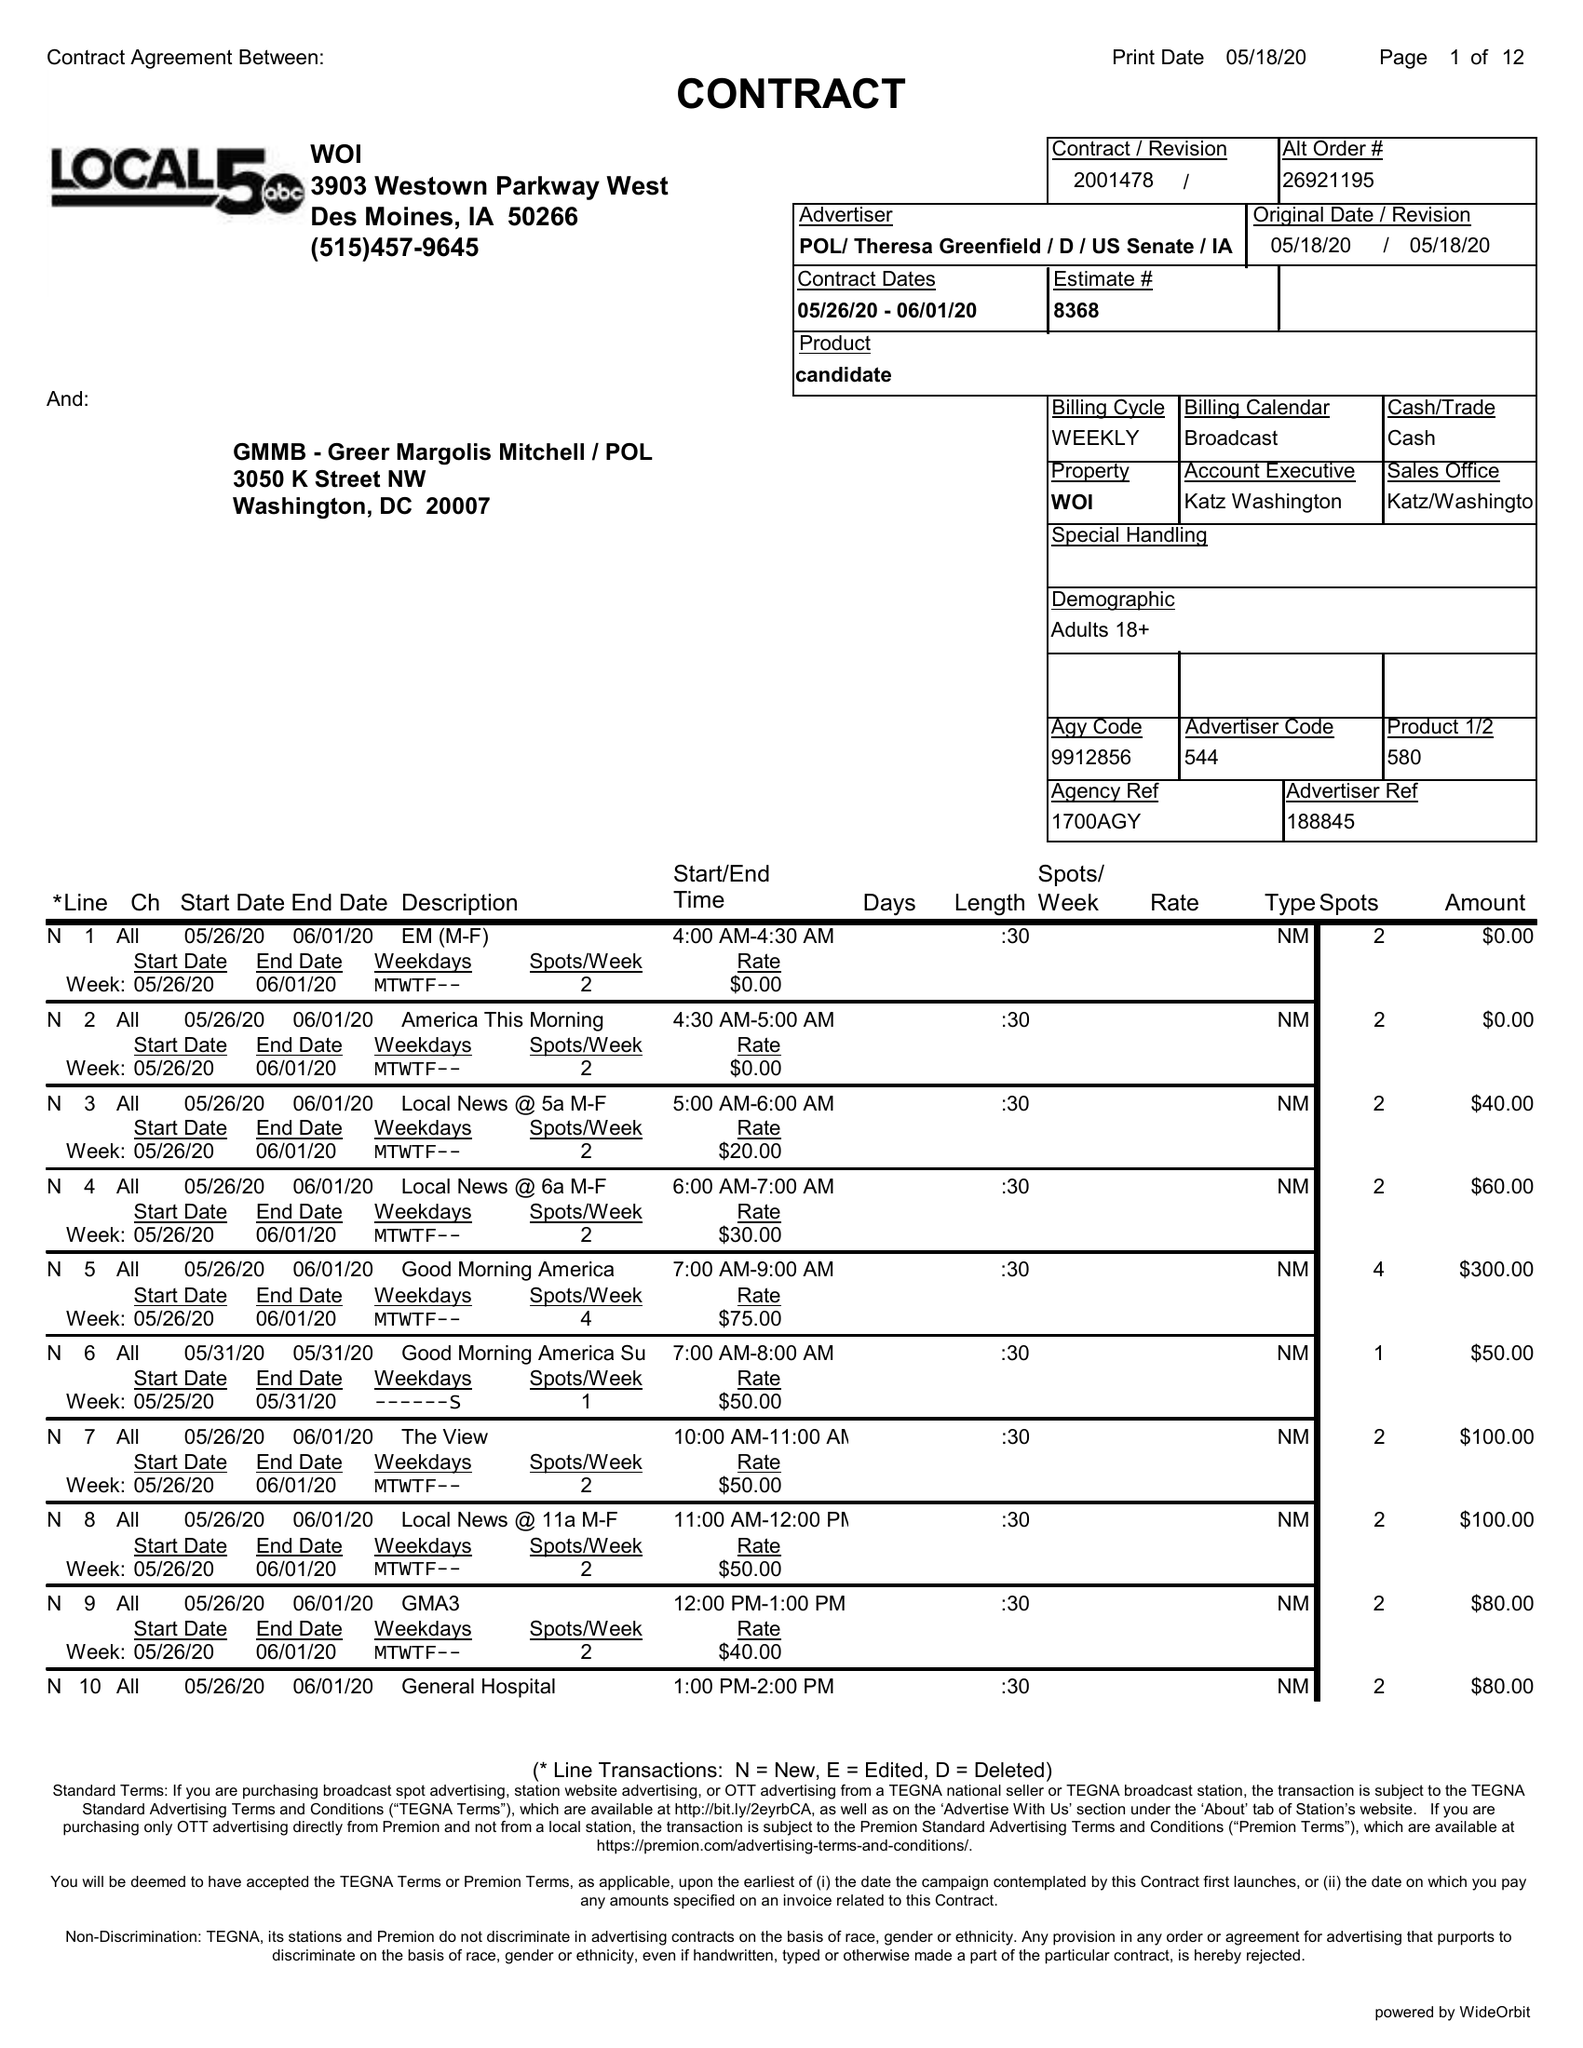What is the value for the contract_num?
Answer the question using a single word or phrase. 2001478 